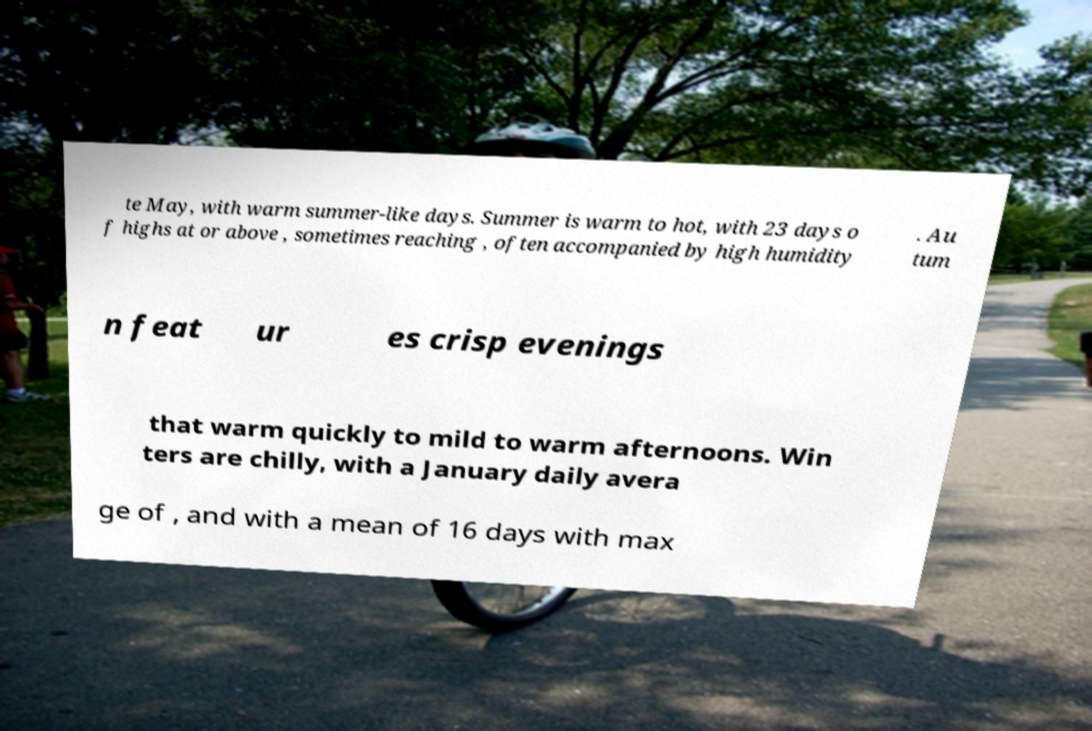Please identify and transcribe the text found in this image. te May, with warm summer-like days. Summer is warm to hot, with 23 days o f highs at or above , sometimes reaching , often accompanied by high humidity . Au tum n feat ur es crisp evenings that warm quickly to mild to warm afternoons. Win ters are chilly, with a January daily avera ge of , and with a mean of 16 days with max 